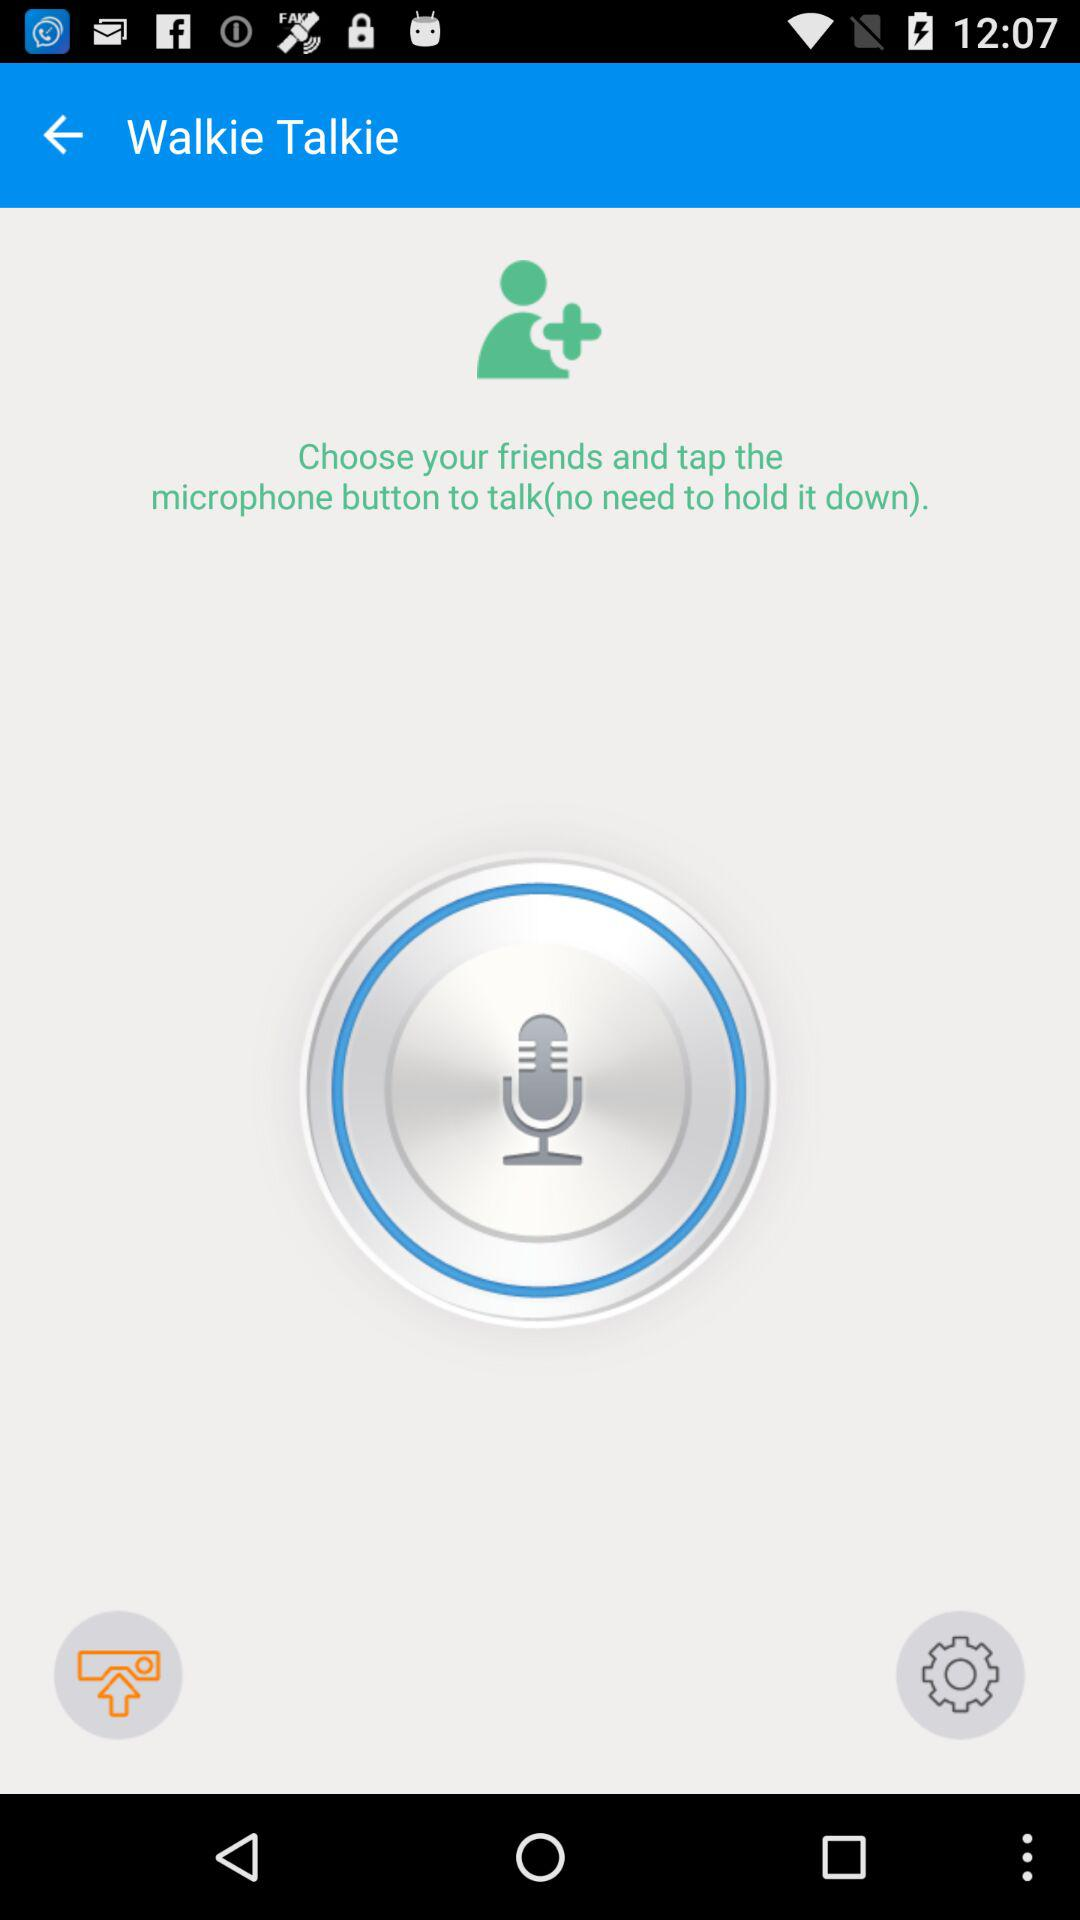What is the name of the application?
When the provided information is insufficient, respond with <no answer>. <no answer> 